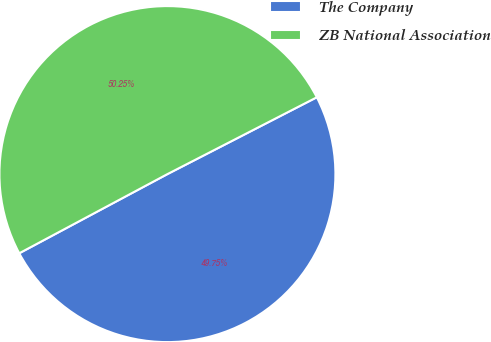Convert chart to OTSL. <chart><loc_0><loc_0><loc_500><loc_500><pie_chart><fcel>The Company<fcel>ZB National Association<nl><fcel>49.75%<fcel>50.25%<nl></chart> 